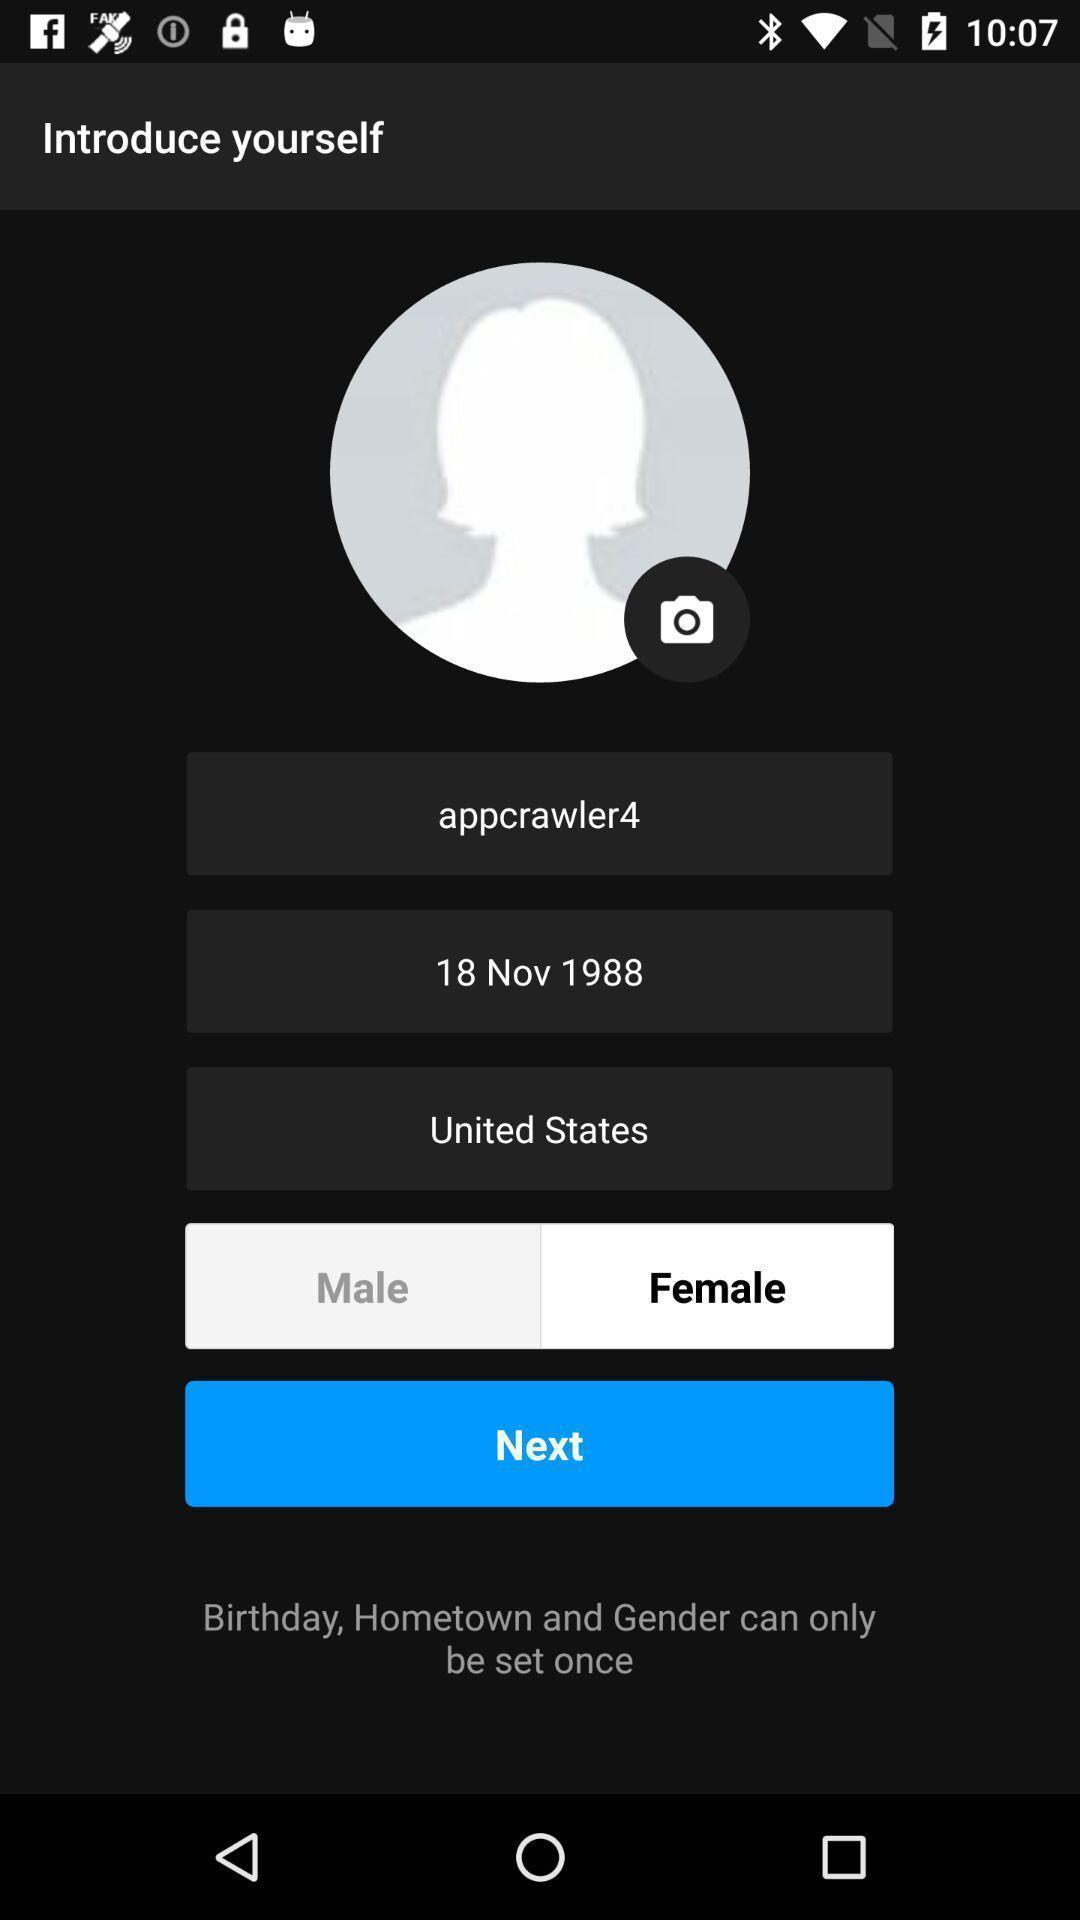Describe the visual elements of this screenshot. Page showing information about profile. 